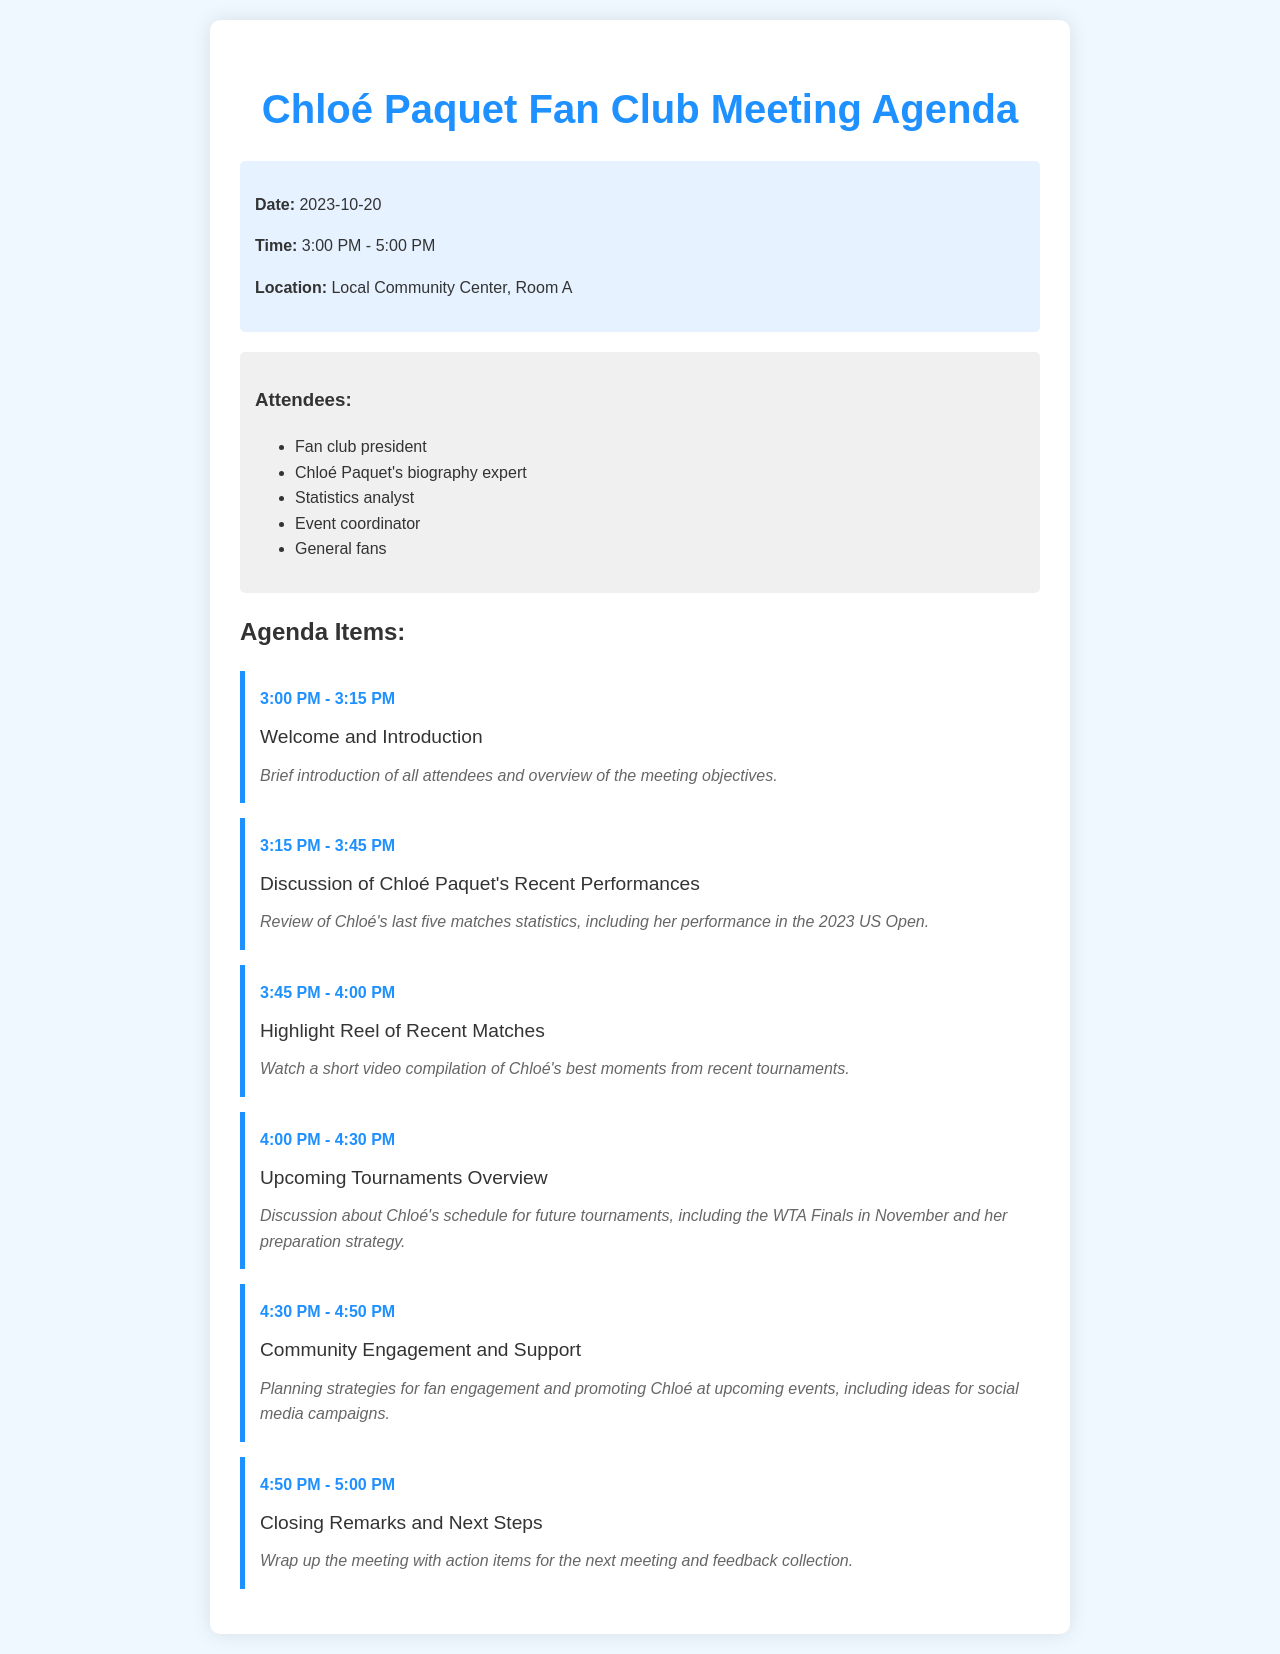What is the date of the meeting? The date of the meeting is specified in the header information of the document.
Answer: 2023-10-20 What time does the meeting start? The starting time of the meeting is mentioned in the header information.
Answer: 3:00 PM How long is the segment for discussing Chloé Paquet's recent performances? The duration of this agenda item is determined by the time slots indicated in the agenda.
Answer: 30 minutes Where is the meeting held? The location of the meeting is provided in the header information.
Answer: Local Community Center, Room A Who is responsible for planning community engagement? The roles of attendees are listed in the document, indicating their responsibilities.
Answer: Event coordinator What is one of the upcoming tournaments discussed? The agenda item mentions specific tournaments scheduled for Chloé Paquet.
Answer: WTA Finals What is the focus of the highlight reel segment? The description of the agenda item explains what the segment will cover.
Answer: Best moments from recent tournaments How many attendees are listed in the document? The number of attendees can be counted from the list provided in the "Attendees" section.
Answer: Five 